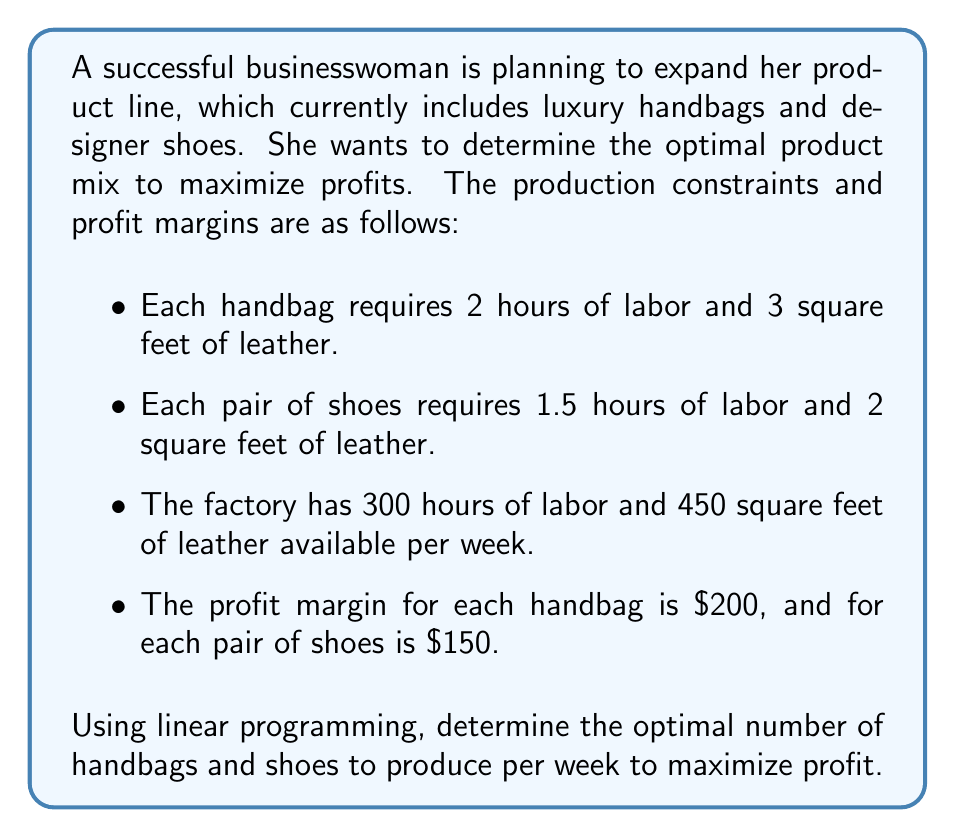Show me your answer to this math problem. Let's approach this problem step by step using linear programming:

1. Define variables:
   Let $x$ = number of handbags
   Let $y$ = number of shoes

2. Objective function (maximize profit):
   $$ \text{Maximize } Z = 200x + 150y $$

3. Constraints:
   Labor constraint: $2x + 1.5y \leq 300$
   Leather constraint: $3x + 2y \leq 450$
   Non-negativity: $x \geq 0, y \geq 0$

4. Graph the constraints:
   [asy]
   import graph;
   size(200,200);
   xaxis("Handbags (x)", 0, 160);
   yaxis("Shoes (y)", 0, 240);
   draw((0,200)--(150,0), blue);
   draw((0,225)--(150,0), red);
   label("Labor", (75,100), W, blue);
   label("Leather", (75,112.5), E, red);
   fill((0,0)--(0,200)--(100,100)--(150,0)--cycle, lightgray);
   [/asy]

5. Find intersection points:
   - Origin: (0, 0)
   - x-intercept for labor: (150, 0)
   - x-intercept for leather: (150, 0)
   - y-intercept for labor: (0, 200)
   - y-intercept for leather: (0, 225)
   - Intersection of constraints:
     Solve $2x + 1.5y = 300$ and $3x + 2y = 450$
     This gives us the point (100, 100)

6. Evaluate objective function at corner points:
   (0, 0): $Z = 0$
   (150, 0): $Z = 30,000$
   (0, 200): $Z = 30,000$
   (0, 225): $Z = 33,750$
   (100, 100): $Z = 35,000$

The maximum profit occurs at the point (100, 100).
Answer: The optimal product mix is to produce 100 handbags and 100 pairs of shoes per week, resulting in a maximum profit of $35,000. 